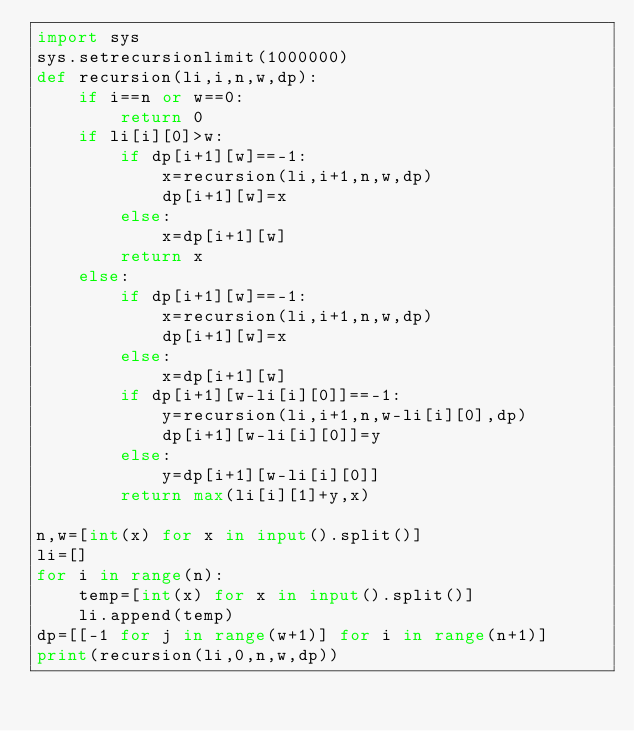<code> <loc_0><loc_0><loc_500><loc_500><_Python_>import sys
sys.setrecursionlimit(1000000)
def recursion(li,i,n,w,dp):
    if i==n or w==0:
        return 0
    if li[i][0]>w:
        if dp[i+1][w]==-1:
            x=recursion(li,i+1,n,w,dp)
            dp[i+1][w]=x            
        else:
            x=dp[i+1][w]
        return x
    else:
        if dp[i+1][w]==-1:
            x=recursion(li,i+1,n,w,dp)
            dp[i+1][w]=x            
        else:
            x=dp[i+1][w]
        if dp[i+1][w-li[i][0]]==-1:
            y=recursion(li,i+1,n,w-li[i][0],dp)
            dp[i+1][w-li[i][0]]=y
        else:
            y=dp[i+1][w-li[i][0]]            
        return max(li[i][1]+y,x)

n,w=[int(x) for x in input().split()]
li=[]
for i in range(n):
    temp=[int(x) for x in input().split()]
    li.append(temp)
dp=[[-1 for j in range(w+1)] for i in range(n+1)]
print(recursion(li,0,n,w,dp))</code> 